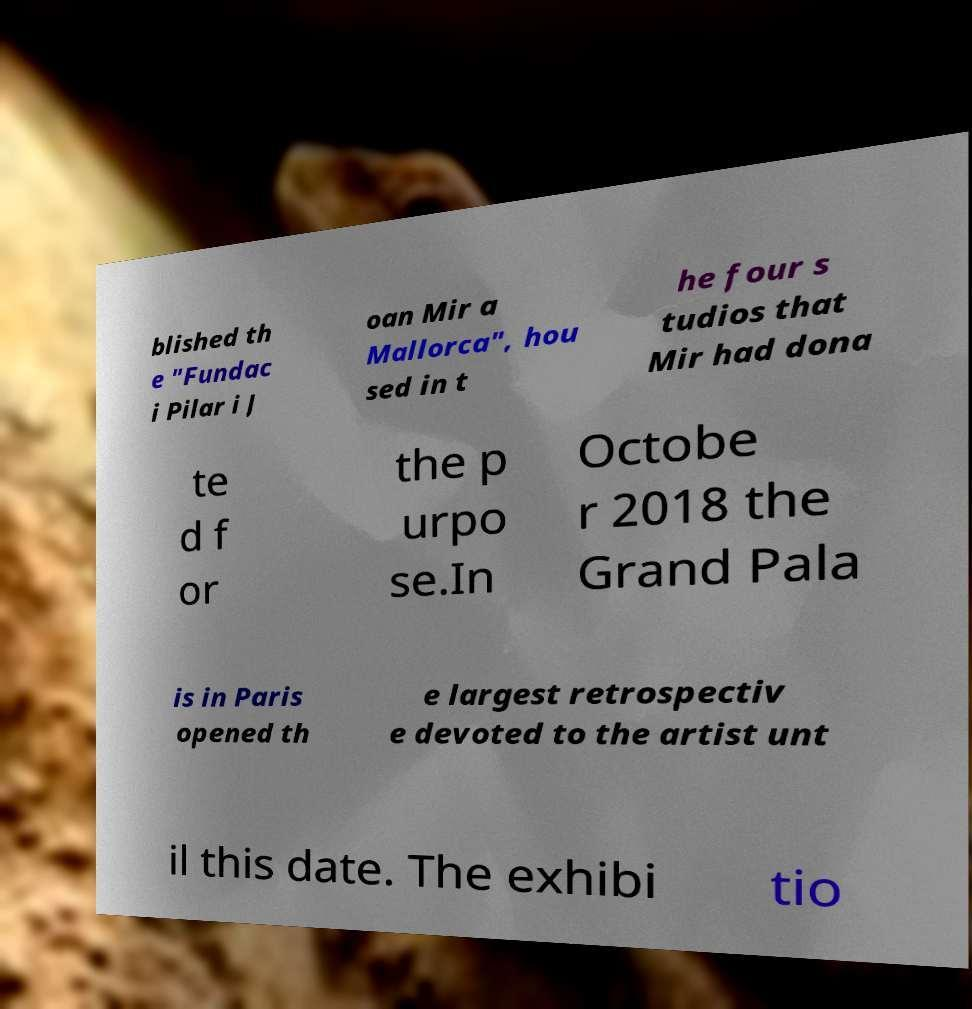There's text embedded in this image that I need extracted. Can you transcribe it verbatim? blished th e "Fundac i Pilar i J oan Mir a Mallorca", hou sed in t he four s tudios that Mir had dona te d f or the p urpo se.In Octobe r 2018 the Grand Pala is in Paris opened th e largest retrospectiv e devoted to the artist unt il this date. The exhibi tio 